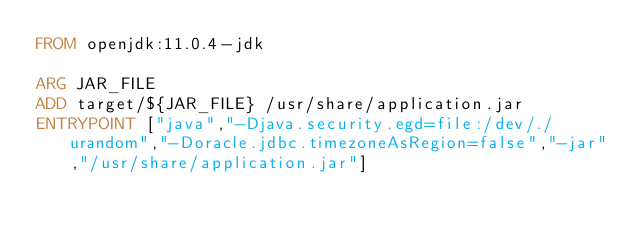<code> <loc_0><loc_0><loc_500><loc_500><_Dockerfile_>FROM openjdk:11.0.4-jdk

ARG JAR_FILE
ADD target/${JAR_FILE} /usr/share/application.jar
ENTRYPOINT ["java","-Djava.security.egd=file:/dev/./urandom","-Doracle.jdbc.timezoneAsRegion=false","-jar","/usr/share/application.jar"]</code> 